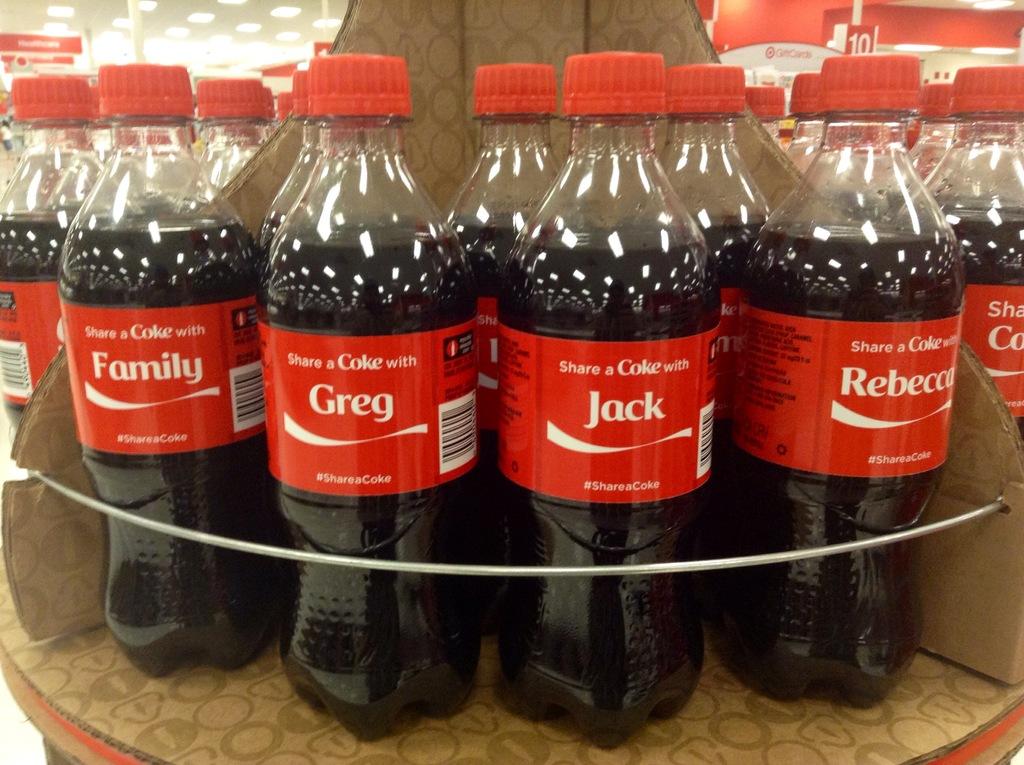What is the word written on the bottle on the far left?
Keep it short and to the point. Family. What name is on the far right?
Your answer should be very brief. Rebecca. 